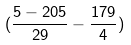Convert formula to latex. <formula><loc_0><loc_0><loc_500><loc_500>( \frac { 5 - 2 0 5 } { 2 9 } - \frac { 1 7 9 } { 4 } )</formula> 